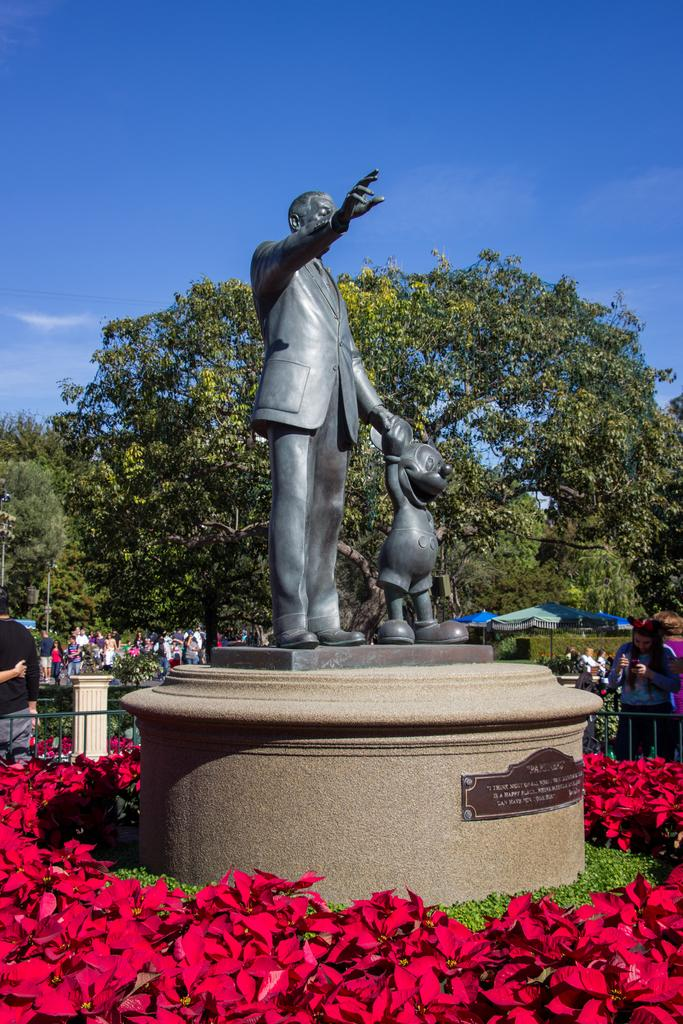What is the main subject in the center of the image? There is a statue in the center of the image. What can be seen at the bottom of the image? There are flowers at the bottom of the image. What type of vegetation is visible in the background of the image? There are trees in the background of the image. What is visible at the top of the image? The sky is visible at the top of the image. How many ministers are present in the image? There are no ministers present in the image. What type of afterthought can be seen in the image? There is no afterthought depicted in the image; it features a statue, flowers, trees, and the sky. 